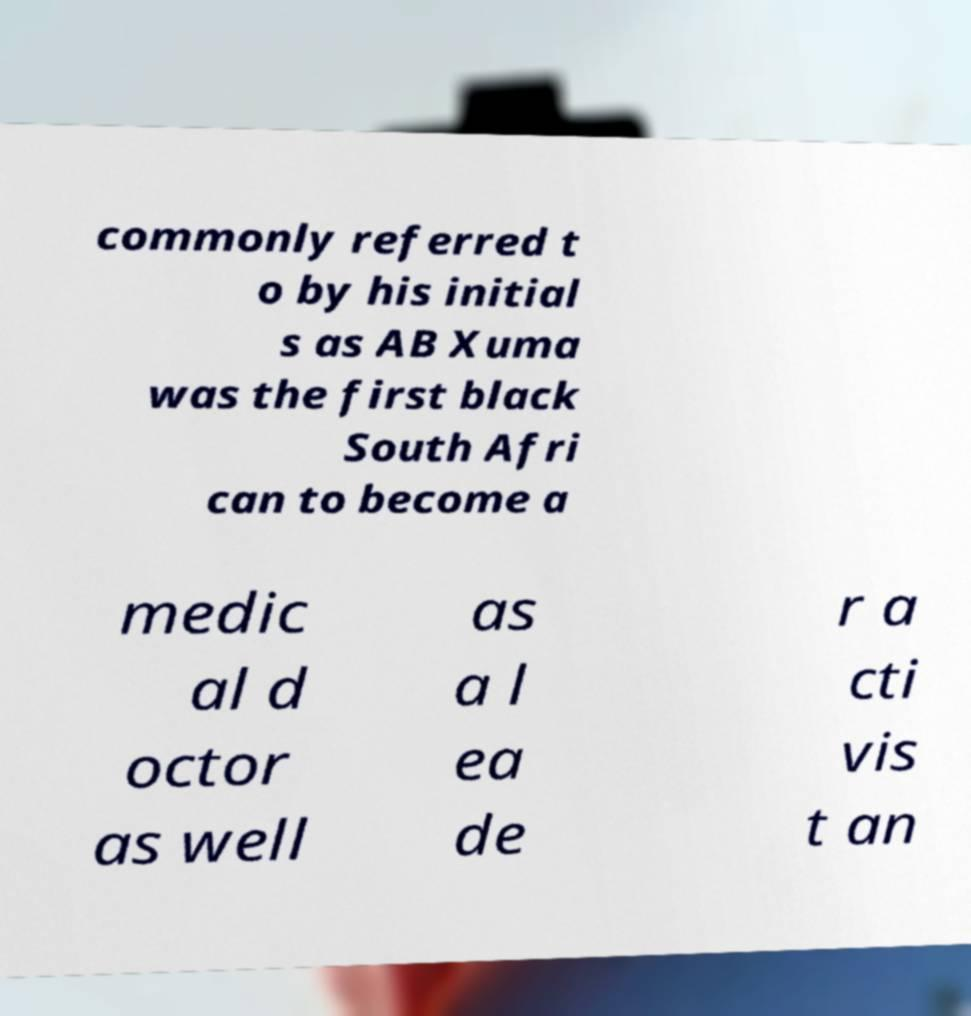Could you assist in decoding the text presented in this image and type it out clearly? commonly referred t o by his initial s as AB Xuma was the first black South Afri can to become a medic al d octor as well as a l ea de r a cti vis t an 